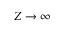<formula> <loc_0><loc_0><loc_500><loc_500>Z \to \infty</formula> 